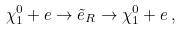<formula> <loc_0><loc_0><loc_500><loc_500>\chi _ { 1 } ^ { 0 } + e \rightarrow { \tilde { e } _ { R } } \rightarrow \chi _ { 1 } ^ { 0 } + e \, ,</formula> 